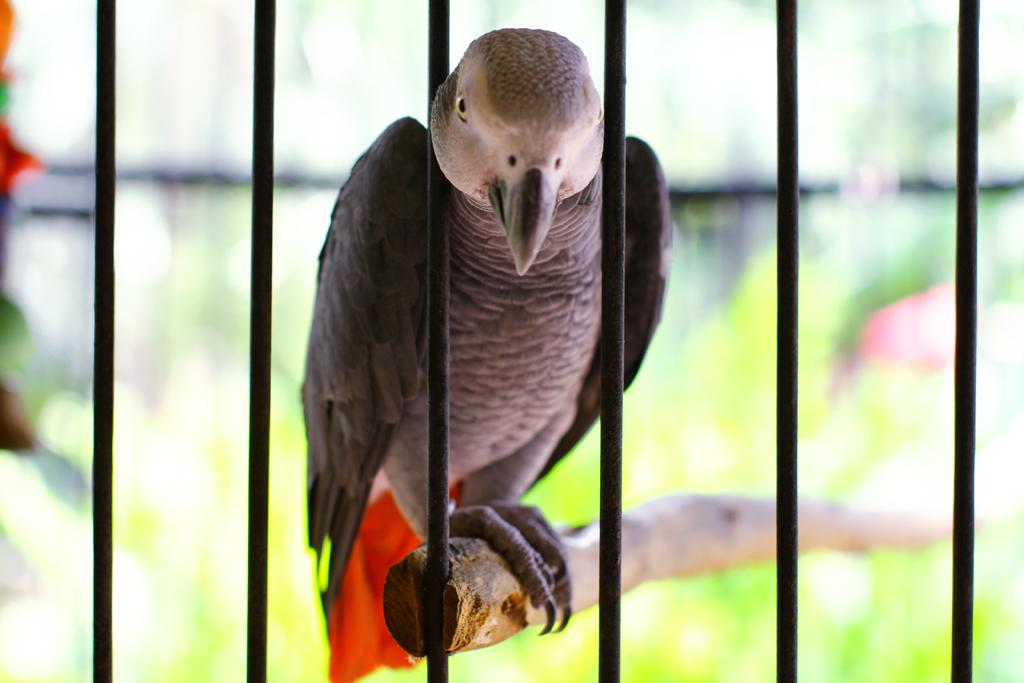What type of animal can be seen in the image? There is a bird in the image. Where is the bird located? The bird is on a log. What other objects are visible in the image? There are grilles visible in the image. Can you describe the background of the image? The background of the image is blurry. What type of basketball game is being played in the background of the image? There is no basketball game present in the image; the background is blurry and does not show any sports activity. 